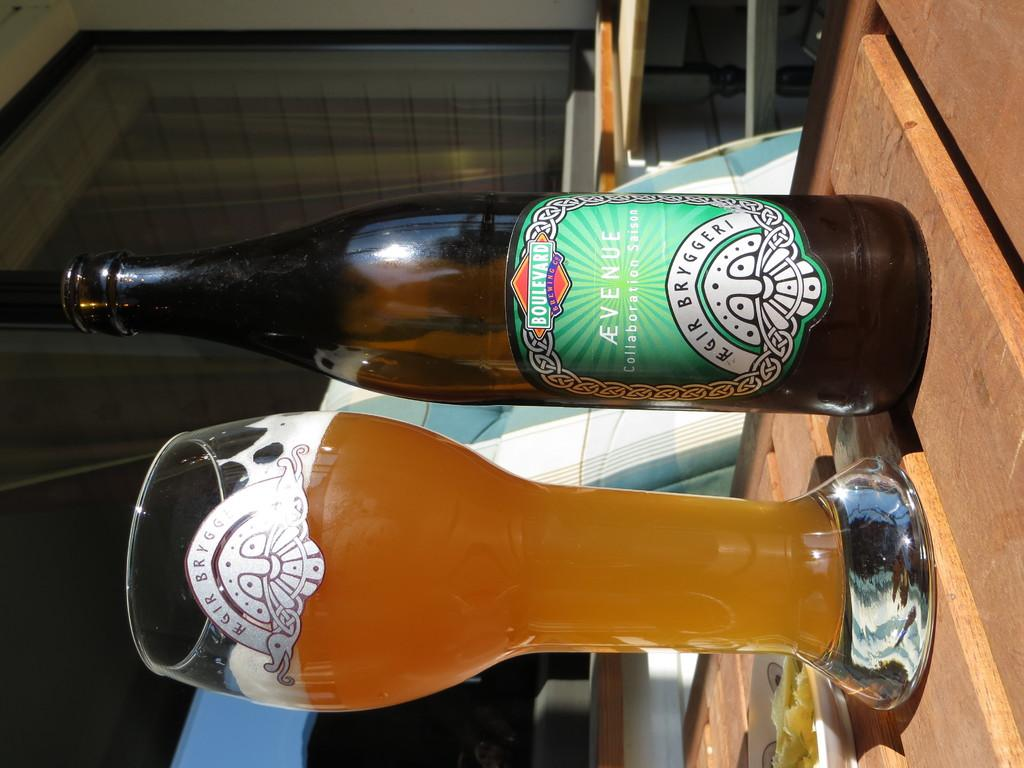<image>
Write a terse but informative summary of the picture. A bottle manufactured by the Boulevard brewing co standing next to a glass 